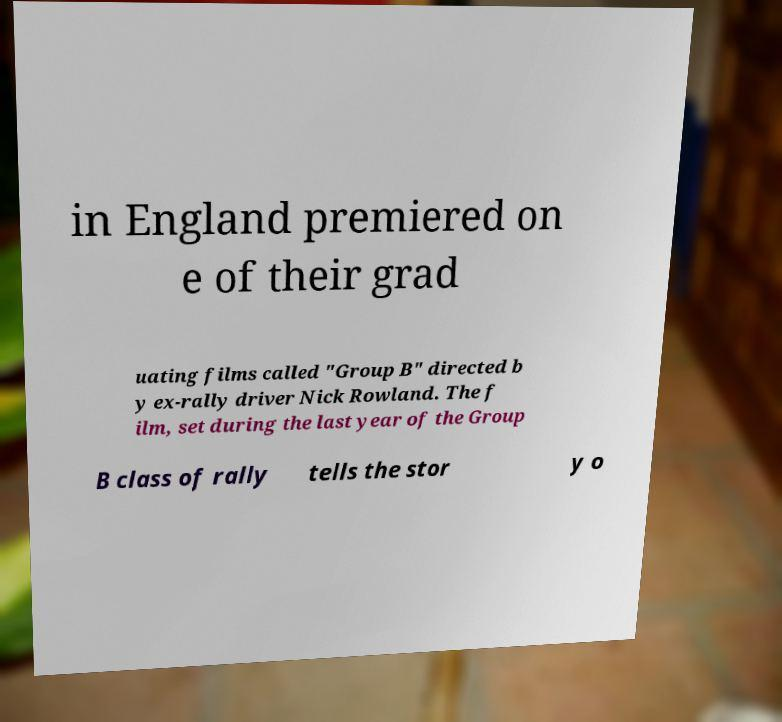Could you extract and type out the text from this image? in England premiered on e of their grad uating films called "Group B" directed b y ex-rally driver Nick Rowland. The f ilm, set during the last year of the Group B class of rally tells the stor y o 